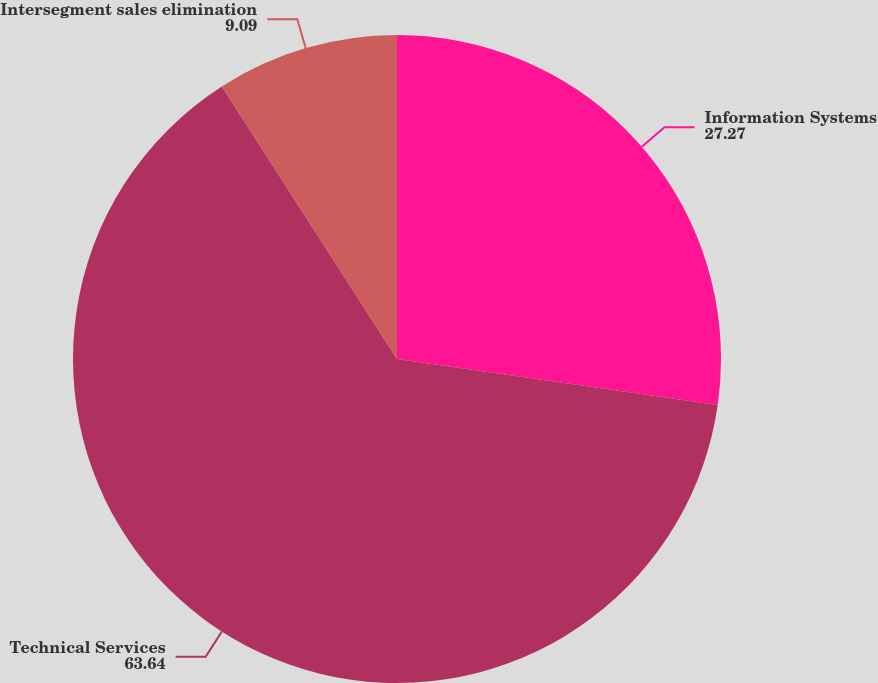Convert chart to OTSL. <chart><loc_0><loc_0><loc_500><loc_500><pie_chart><fcel>Information Systems<fcel>Technical Services<fcel>Intersegment sales elimination<nl><fcel>27.27%<fcel>63.64%<fcel>9.09%<nl></chart> 